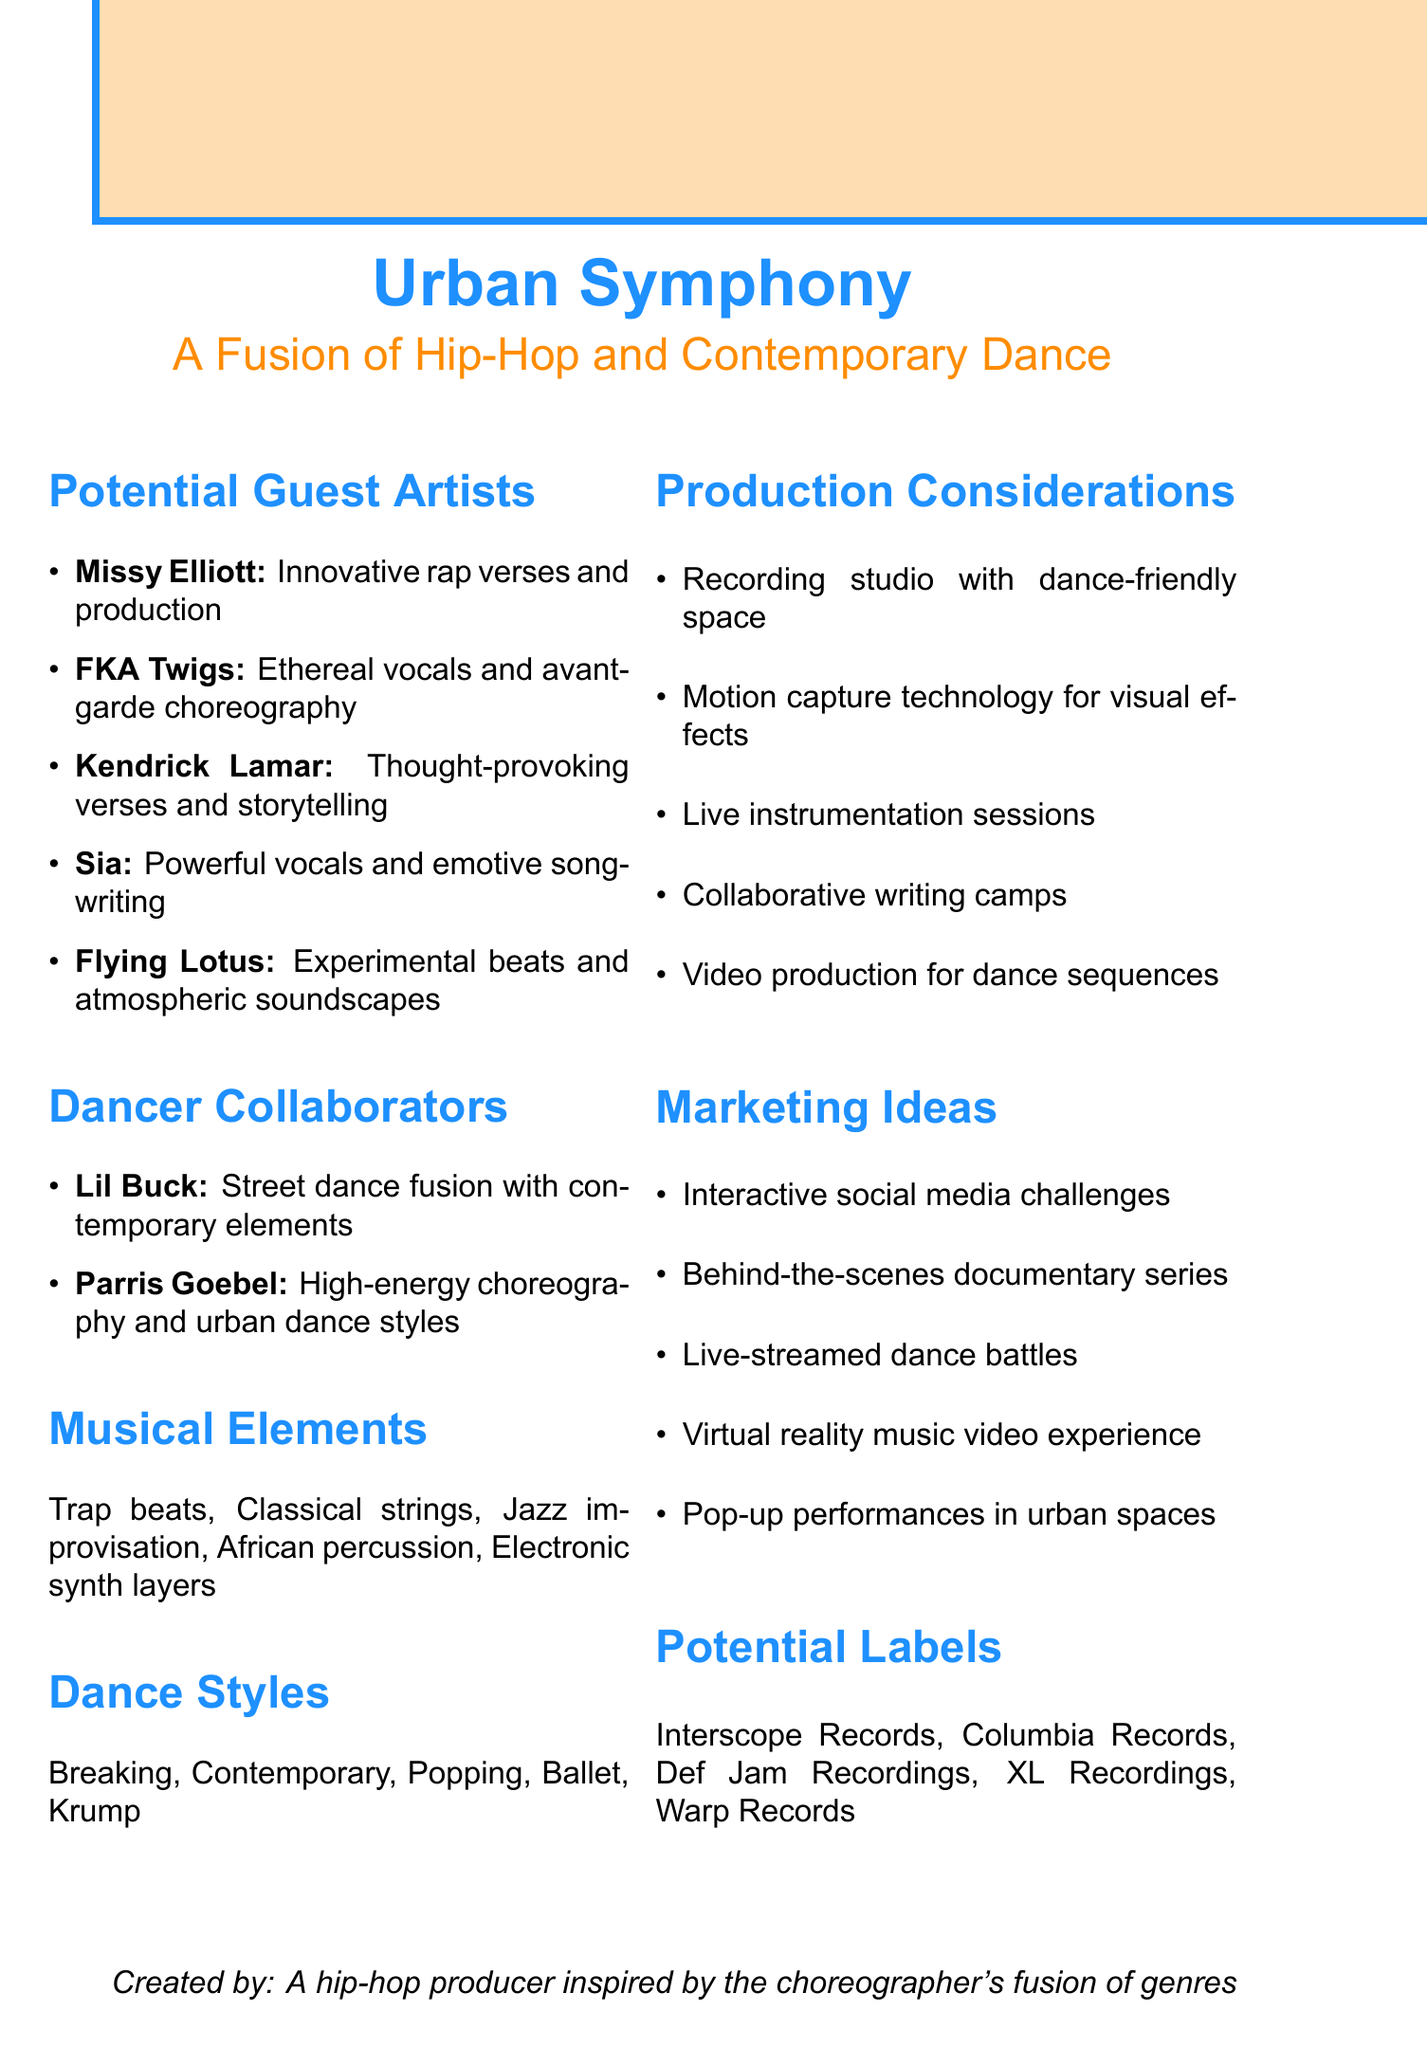What is the album concept? The album concept describes the overall theme and style, which is a fusion of hip-hop and contemporary dance.
Answer: Urban Symphony: A Fusion of Hip-Hop and Contemporary Dance Who are the potential guest artists? This question asks for the names of the artists listed in the document under potential guest artists.
Answer: Missy Elliott, FKA Twigs, Kendrick Lamar, Sia, Flying Lotus What is one of the marketing ideas mentioned? The marketing ideas section lists various promotional strategies for the album.
Answer: Interactive social media challenges Which label is listed as a potential label for the album? This asks for one of the record labels that might produce the album as mentioned in the document.
Answer: Interscope Records What dance style is contributed by Lil Buck? The contribution of Lil Buck is specifically mentioned in terms of dance style.
Answer: Jookin What musical element involves classical instruments? This question relates to the musical elements that combine different styles.
Answer: Classical string arrangements What type of technology is suggested for visual effects? The document discusses production considerations including technological enhancements.
Answer: Motion capture technology How many dancer collaborators are mentioned? This asks for the count of unique dancer collaborators present in the document.
Answer: 2 What kind of production sessions are suggested? This question asks for a specific type of session mentioned under production considerations.
Answer: Live instrumentation sessions 